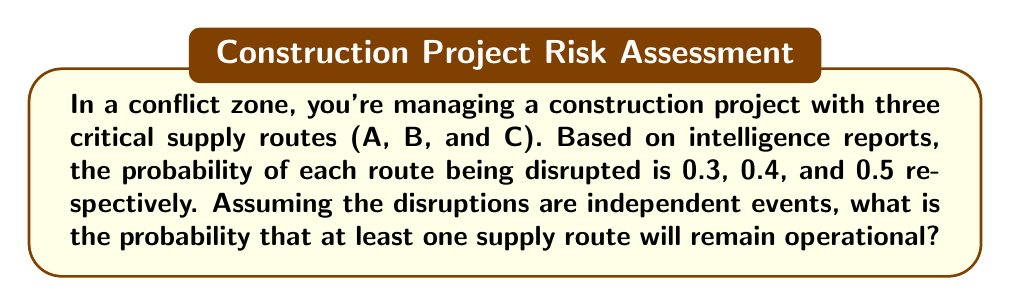What is the answer to this math problem? Let's approach this step-by-step using the principles of probability:

1) First, let's define our events:
   A: Route A is disrupted
   B: Route B is disrupted
   C: Route C is disrupted

2) We're given the probabilities:
   P(A) = 0.3
   P(B) = 0.4
   P(C) = 0.5

3) We want to find the probability that at least one route remains operational. This is equivalent to the probability that not all routes are disrupted.

4) The probability that all routes are disrupted is:
   P(A and B and C) = P(A) × P(B) × P(C)  (since events are independent)
   
   $$P(A \text{ and } B \text{ and } C) = 0.3 \times 0.4 \times 0.5 = 0.06$$

5) Therefore, the probability that at least one route remains operational is:
   P(at least one operational) = 1 - P(all disrupted)
   
   $$P(\text{at least one operational}) = 1 - 0.06 = 0.94$$

6) We can also calculate this using the complement rule:
   P(at least one operational) = 1 - P(all disrupted)
                                = 1 - [P(A) × P(B) × P(C)]
                                = 1 - [(0.3) × (0.4) × (0.5)]
                                = 1 - 0.06
                                = 0.94

Thus, there is a 94% chance that at least one supply route will remain operational.
Answer: 0.94 or 94% 